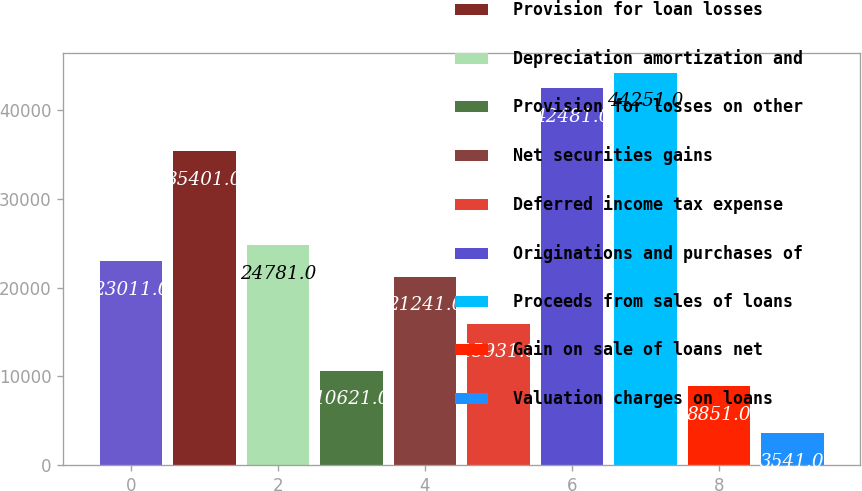<chart> <loc_0><loc_0><loc_500><loc_500><bar_chart><fcel>Net income (loss)<fcel>Provision for loan losses<fcel>Depreciation amortization and<fcel>Provision for losses on other<fcel>Net securities gains<fcel>Deferred income tax expense<fcel>Originations and purchases of<fcel>Proceeds from sales of loans<fcel>Gain on sale of loans net<fcel>Valuation charges on loans<nl><fcel>23011<fcel>35401<fcel>24781<fcel>10621<fcel>21241<fcel>15931<fcel>42481<fcel>44251<fcel>8851<fcel>3541<nl></chart> 